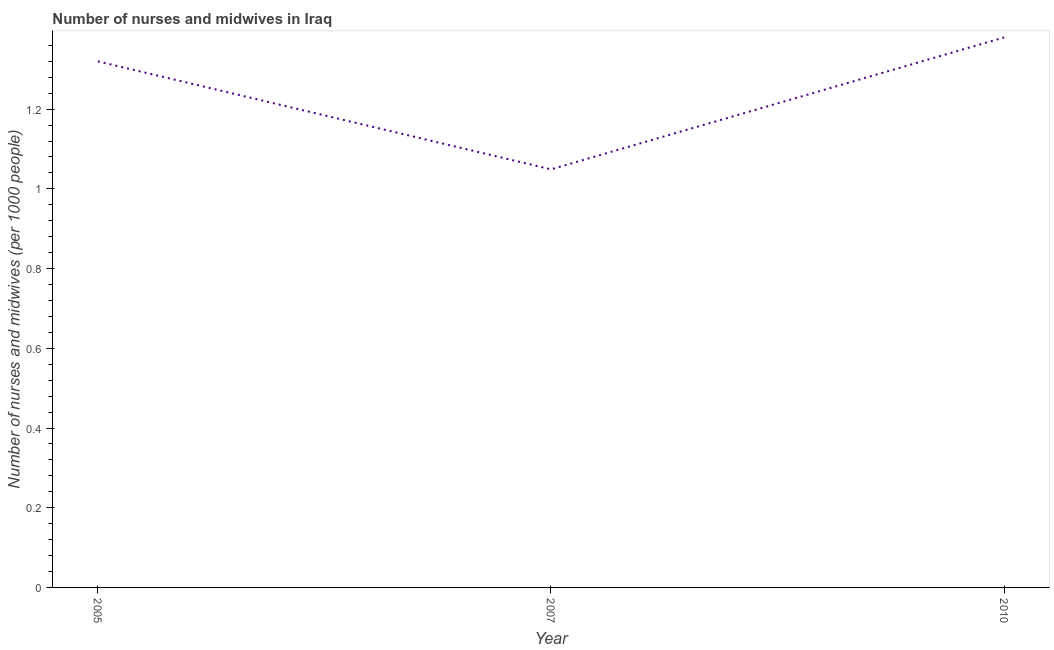What is the number of nurses and midwives in 2005?
Make the answer very short. 1.32. Across all years, what is the maximum number of nurses and midwives?
Provide a short and direct response. 1.38. Across all years, what is the minimum number of nurses and midwives?
Your answer should be compact. 1.05. In which year was the number of nurses and midwives minimum?
Offer a terse response. 2007. What is the sum of the number of nurses and midwives?
Make the answer very short. 3.75. What is the difference between the number of nurses and midwives in 2005 and 2007?
Make the answer very short. 0.27. What is the average number of nurses and midwives per year?
Make the answer very short. 1.25. What is the median number of nurses and midwives?
Offer a very short reply. 1.32. Do a majority of the years between 2010 and 2007 (inclusive) have number of nurses and midwives greater than 0.04 ?
Your answer should be very brief. No. What is the ratio of the number of nurses and midwives in 2007 to that in 2010?
Your answer should be compact. 0.76. Is the number of nurses and midwives in 2005 less than that in 2007?
Provide a succinct answer. No. What is the difference between the highest and the second highest number of nurses and midwives?
Make the answer very short. 0.06. Is the sum of the number of nurses and midwives in 2007 and 2010 greater than the maximum number of nurses and midwives across all years?
Provide a short and direct response. Yes. What is the difference between the highest and the lowest number of nurses and midwives?
Your answer should be very brief. 0.33. How many years are there in the graph?
Provide a short and direct response. 3. Are the values on the major ticks of Y-axis written in scientific E-notation?
Keep it short and to the point. No. Does the graph contain grids?
Keep it short and to the point. No. What is the title of the graph?
Offer a very short reply. Number of nurses and midwives in Iraq. What is the label or title of the X-axis?
Give a very brief answer. Year. What is the label or title of the Y-axis?
Keep it short and to the point. Number of nurses and midwives (per 1000 people). What is the Number of nurses and midwives (per 1000 people) of 2005?
Your answer should be very brief. 1.32. What is the Number of nurses and midwives (per 1000 people) in 2007?
Make the answer very short. 1.05. What is the Number of nurses and midwives (per 1000 people) of 2010?
Offer a very short reply. 1.38. What is the difference between the Number of nurses and midwives (per 1000 people) in 2005 and 2007?
Your answer should be compact. 0.27. What is the difference between the Number of nurses and midwives (per 1000 people) in 2005 and 2010?
Your response must be concise. -0.06. What is the difference between the Number of nurses and midwives (per 1000 people) in 2007 and 2010?
Provide a succinct answer. -0.33. What is the ratio of the Number of nurses and midwives (per 1000 people) in 2005 to that in 2007?
Give a very brief answer. 1.26. What is the ratio of the Number of nurses and midwives (per 1000 people) in 2007 to that in 2010?
Ensure brevity in your answer.  0.76. 